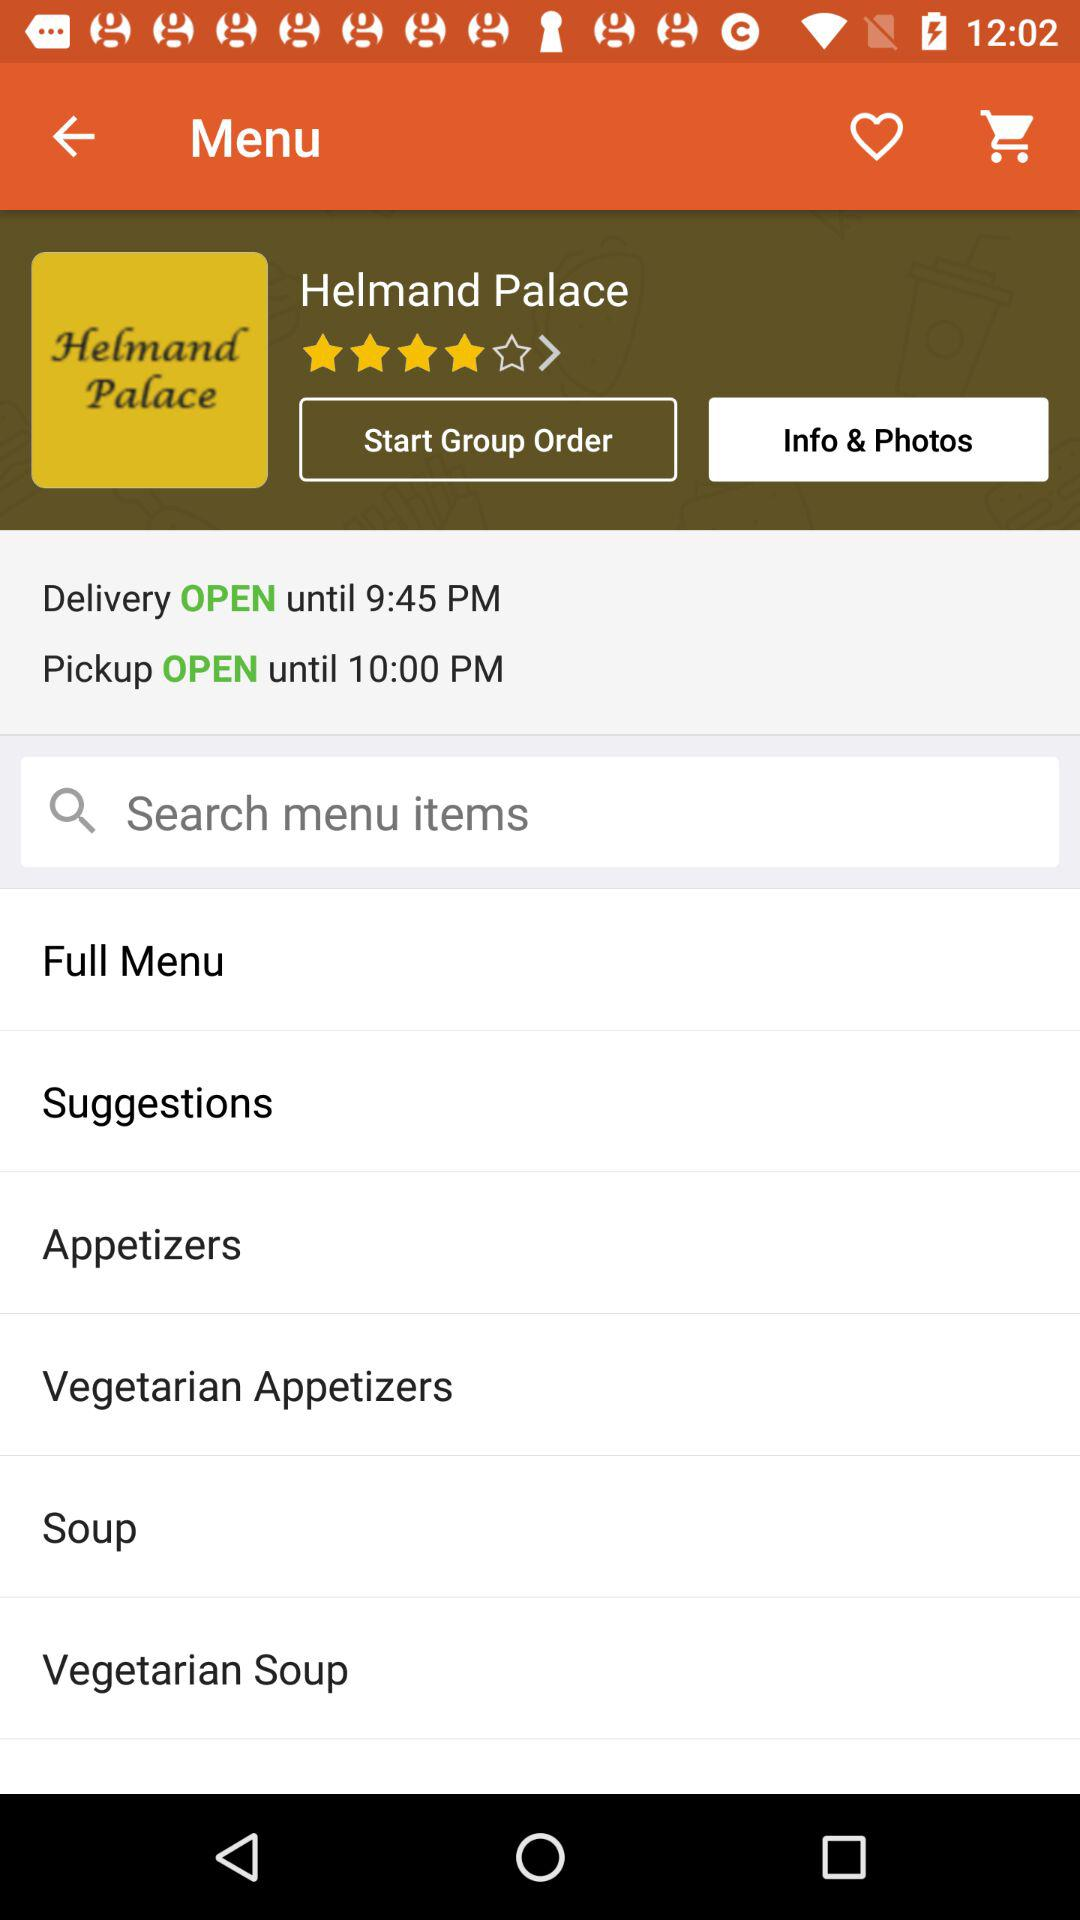What is the rating? The rating is 4 stars. 